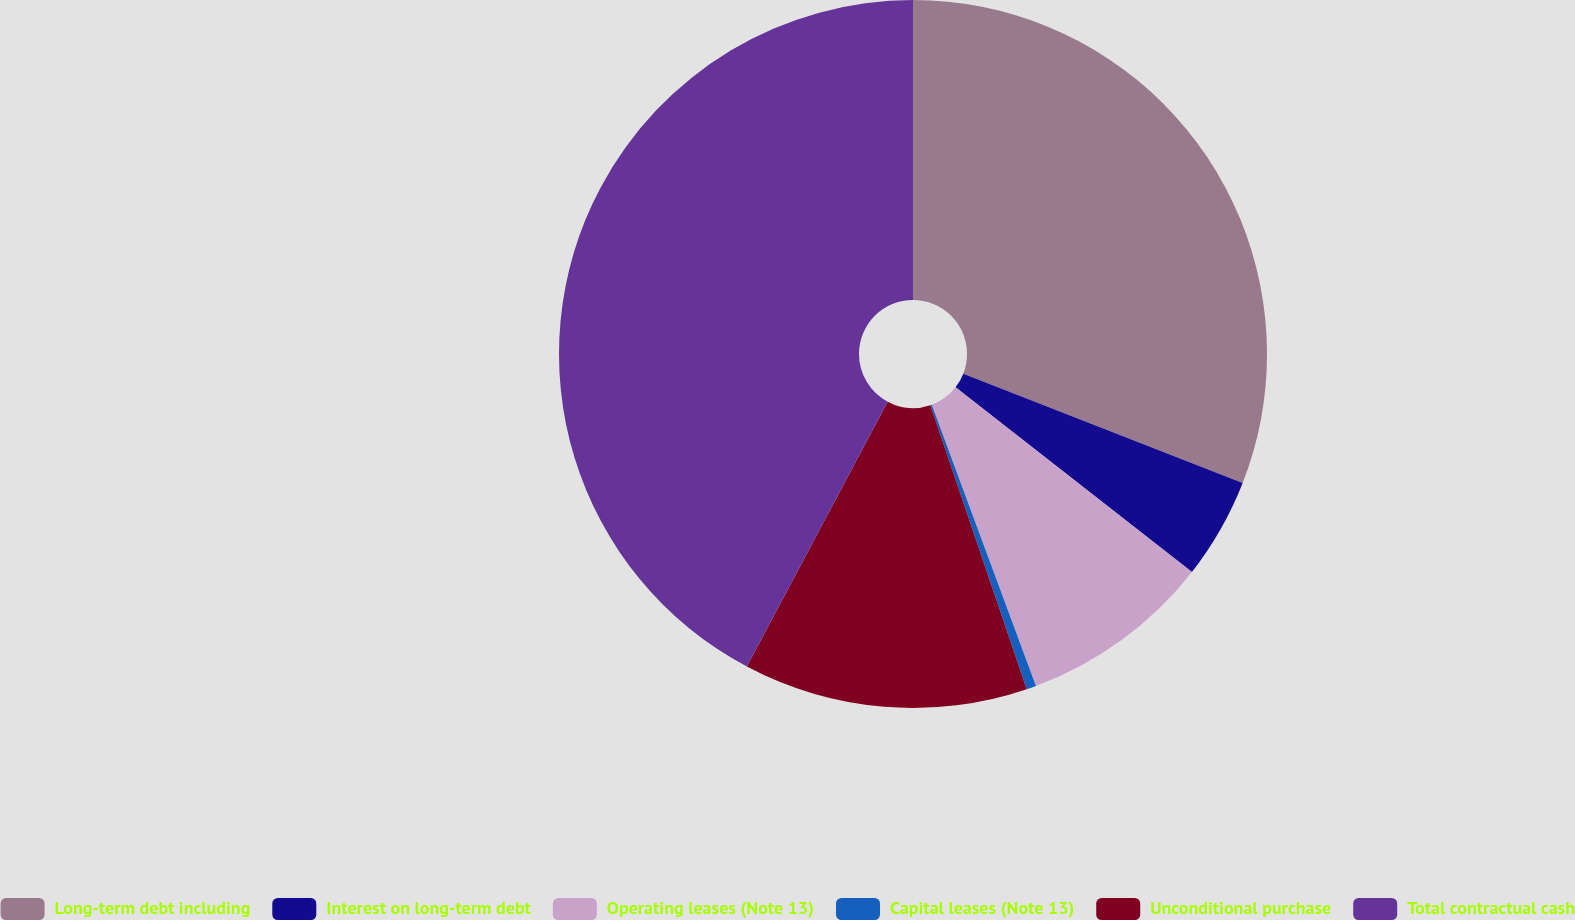Convert chart to OTSL. <chart><loc_0><loc_0><loc_500><loc_500><pie_chart><fcel>Long-term debt including<fcel>Interest on long-term debt<fcel>Operating leases (Note 13)<fcel>Capital leases (Note 13)<fcel>Unconditional purchase<fcel>Total contractual cash<nl><fcel>30.94%<fcel>4.62%<fcel>8.8%<fcel>0.44%<fcel>12.98%<fcel>42.23%<nl></chart> 